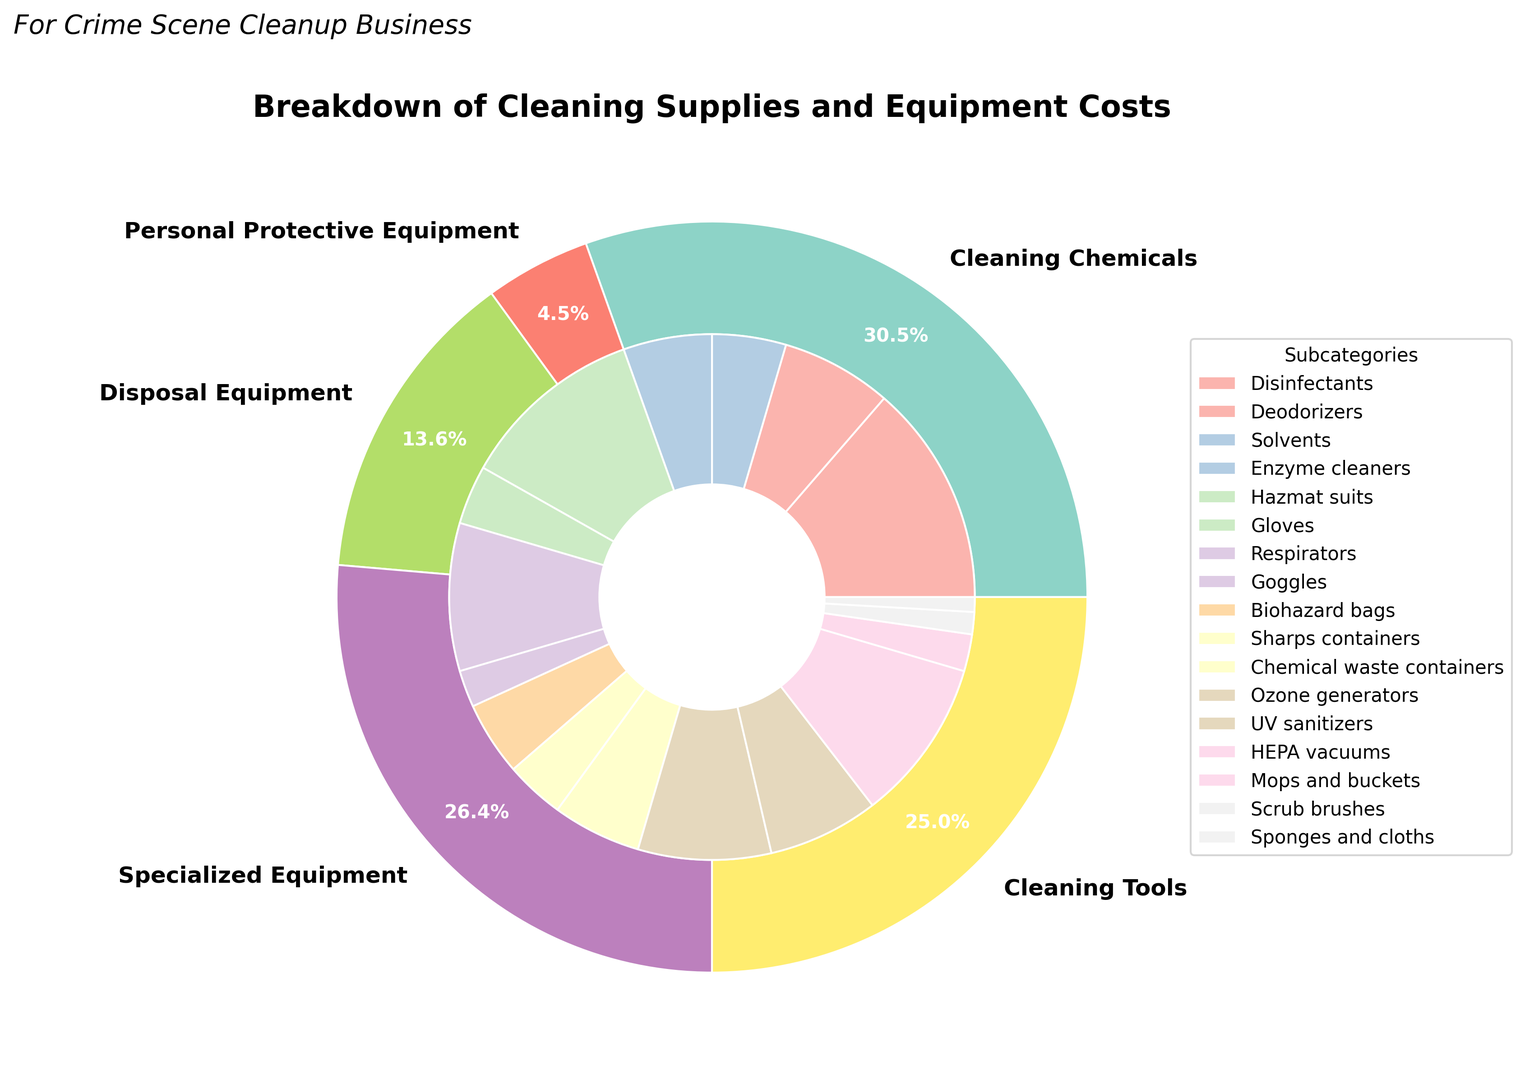What percentage of the total cost is attributed to Cleaning Chemicals? First, identify the segment representing Cleaning Chemicals from the outer ring of the chart. The percentage value inside the Cleaning Chemicals segment shows the proportion.
Answer: 31.4% What is the combined cost of Hazmat suits and Respirators? Locate the segments for Hazmat suits and Respirators in the inner ring. Add their costs: Hazmat suits (25) + Respirators (20) = 45.
Answer: 45 Which subcategory has the smallest cost, and what is its value? Examine the smallest segment in the inner ring, which represents the subcategory with the least cost. The segment for Sponges and cloths shows the smallest cost, which is 2.
Answer: Sponges and cloths, 2 How do the costs of Biohazard bags compare to Chemical waste containers? Find the segments for both Biohazard bags and Chemical waste containers in the inner ring. Biohazard bags cost 10 and Chemical waste containers cost 12, so Chemical waste containers cost more.
Answer: Biohazard bags < Chemical waste containers What's the difference in cost between Cleaning Tools and Specialized Equipment? Sum the costs of all subcategories in Cleaning Tools and in Specialized Equipment. Cleaning Tools: 5 (Mops and buckets) + 3 (Scrub brushes) + 2 (Sponges and cloths) = 10. Specialized Equipment: 18 (Ozone generators) + 15 (UV sanitizers) + 22 (HEPA vacuums) = 55. The difference is: 55 - 10 = 45.
Answer: 45 Which category has the highest total cost, and what is its value? From the outer ring, find the segment with the highest percentage label. Specialized Equipment has the highest value, showing a total cost of 55.
Answer: Specialized Equipment, 55 What is the average cost of Personal Protective Equipment subcategories? Sum the costs of all subcategories under Personal Protective Equipment and divide by the number of subcategories. Hazmat suits (25) + Gloves (8) + Respirators (20) + Goggles (5) = 58. There are 4 subcategories, so the average is 58/4 = 14.5.
Answer: 14.5 What's the total cost for all subcategories under Disposal Equipment? Add the costs of Biohazard bags (10), Sharps containers (8), and Chemical waste containers (12). The total is 10 + 8 + 12 = 30.
Answer: 30 Is the cost of UV sanitizers more or less than HEPA vacuums? Compare the costs of UV sanitizers (15) and HEPA vacuums (22). UV sanitizers cost less than HEPA vacuums.
Answer: Less 